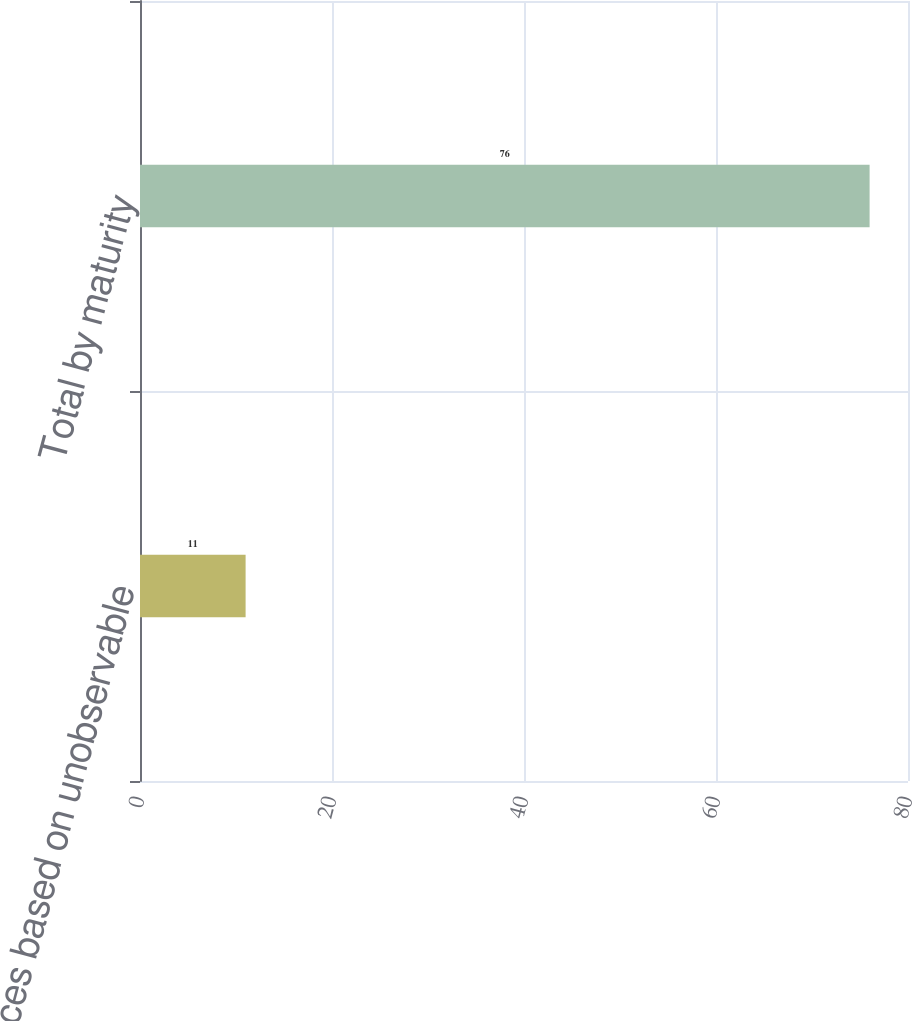Convert chart to OTSL. <chart><loc_0><loc_0><loc_500><loc_500><bar_chart><fcel>Prices based on unobservable<fcel>Total by maturity<nl><fcel>11<fcel>76<nl></chart> 